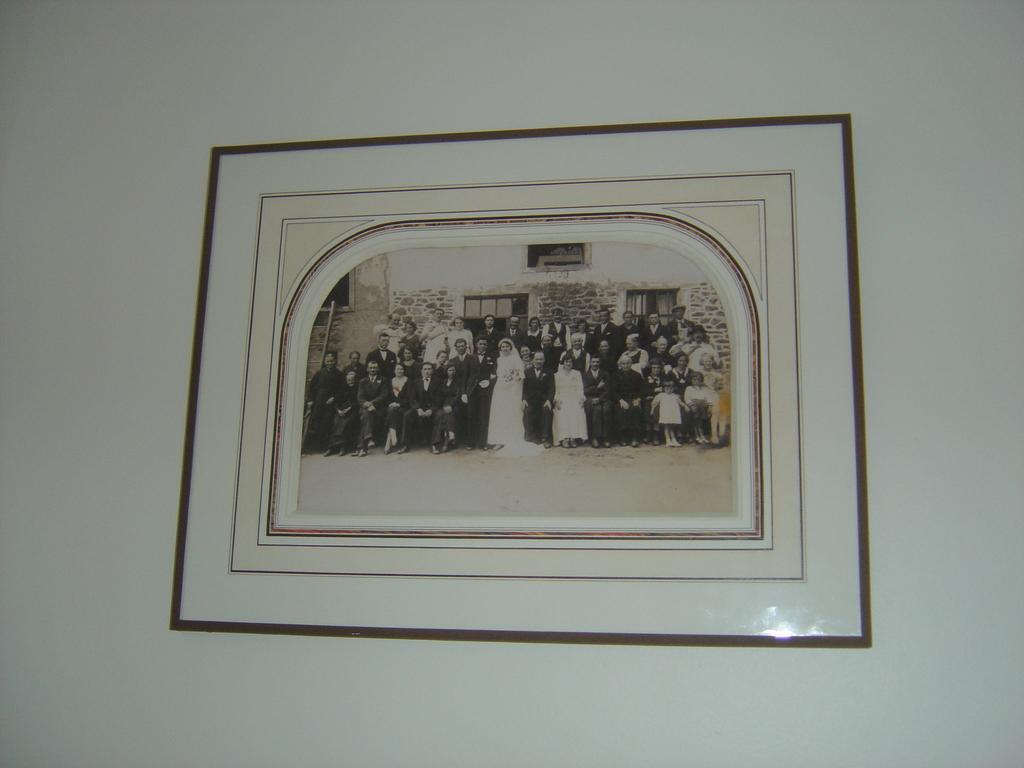Could you give a brief overview of what you see in this image? In this picture I can observe photo frame on the wall. In this photo frame I can observe group of people. 